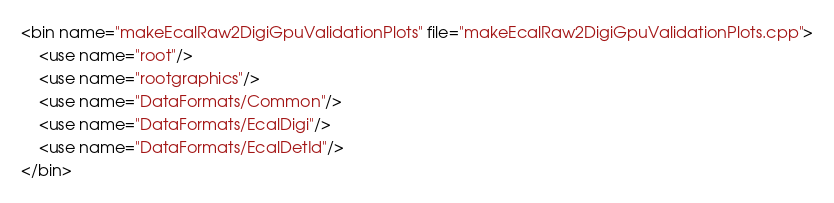Convert code to text. <code><loc_0><loc_0><loc_500><loc_500><_XML_><bin name="makeEcalRaw2DigiGpuValidationPlots" file="makeEcalRaw2DigiGpuValidationPlots.cpp">
    <use name="root"/>
    <use name="rootgraphics"/>
    <use name="DataFormats/Common"/>
    <use name="DataFormats/EcalDigi"/>
    <use name="DataFormats/EcalDetId"/>
</bin>
</code> 